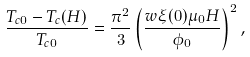<formula> <loc_0><loc_0><loc_500><loc_500>\frac { T _ { c 0 } - T _ { c } ( H ) } { T _ { c 0 } } = \frac { \pi ^ { 2 } } { 3 } \left ( \frac { w \xi ( 0 ) \mu _ { 0 } H } { \phi _ { 0 } } \right ) ^ { 2 } ,</formula> 